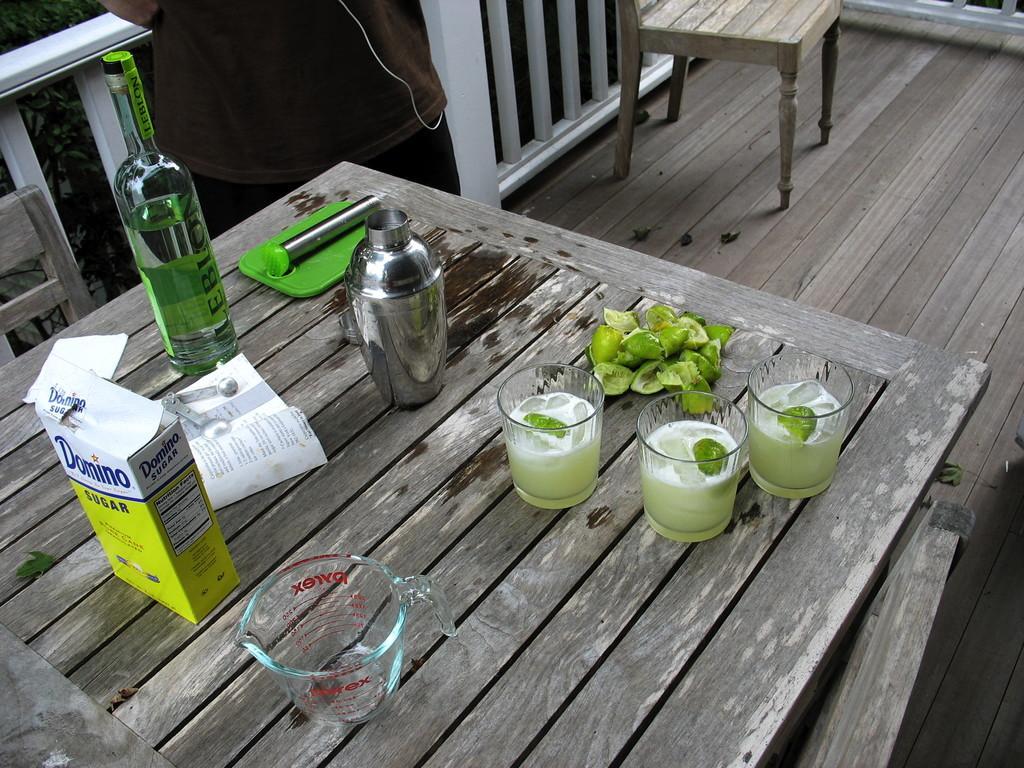Could you give a brief overview of what you see in this image? There are glasses jug and bottle on the table. 